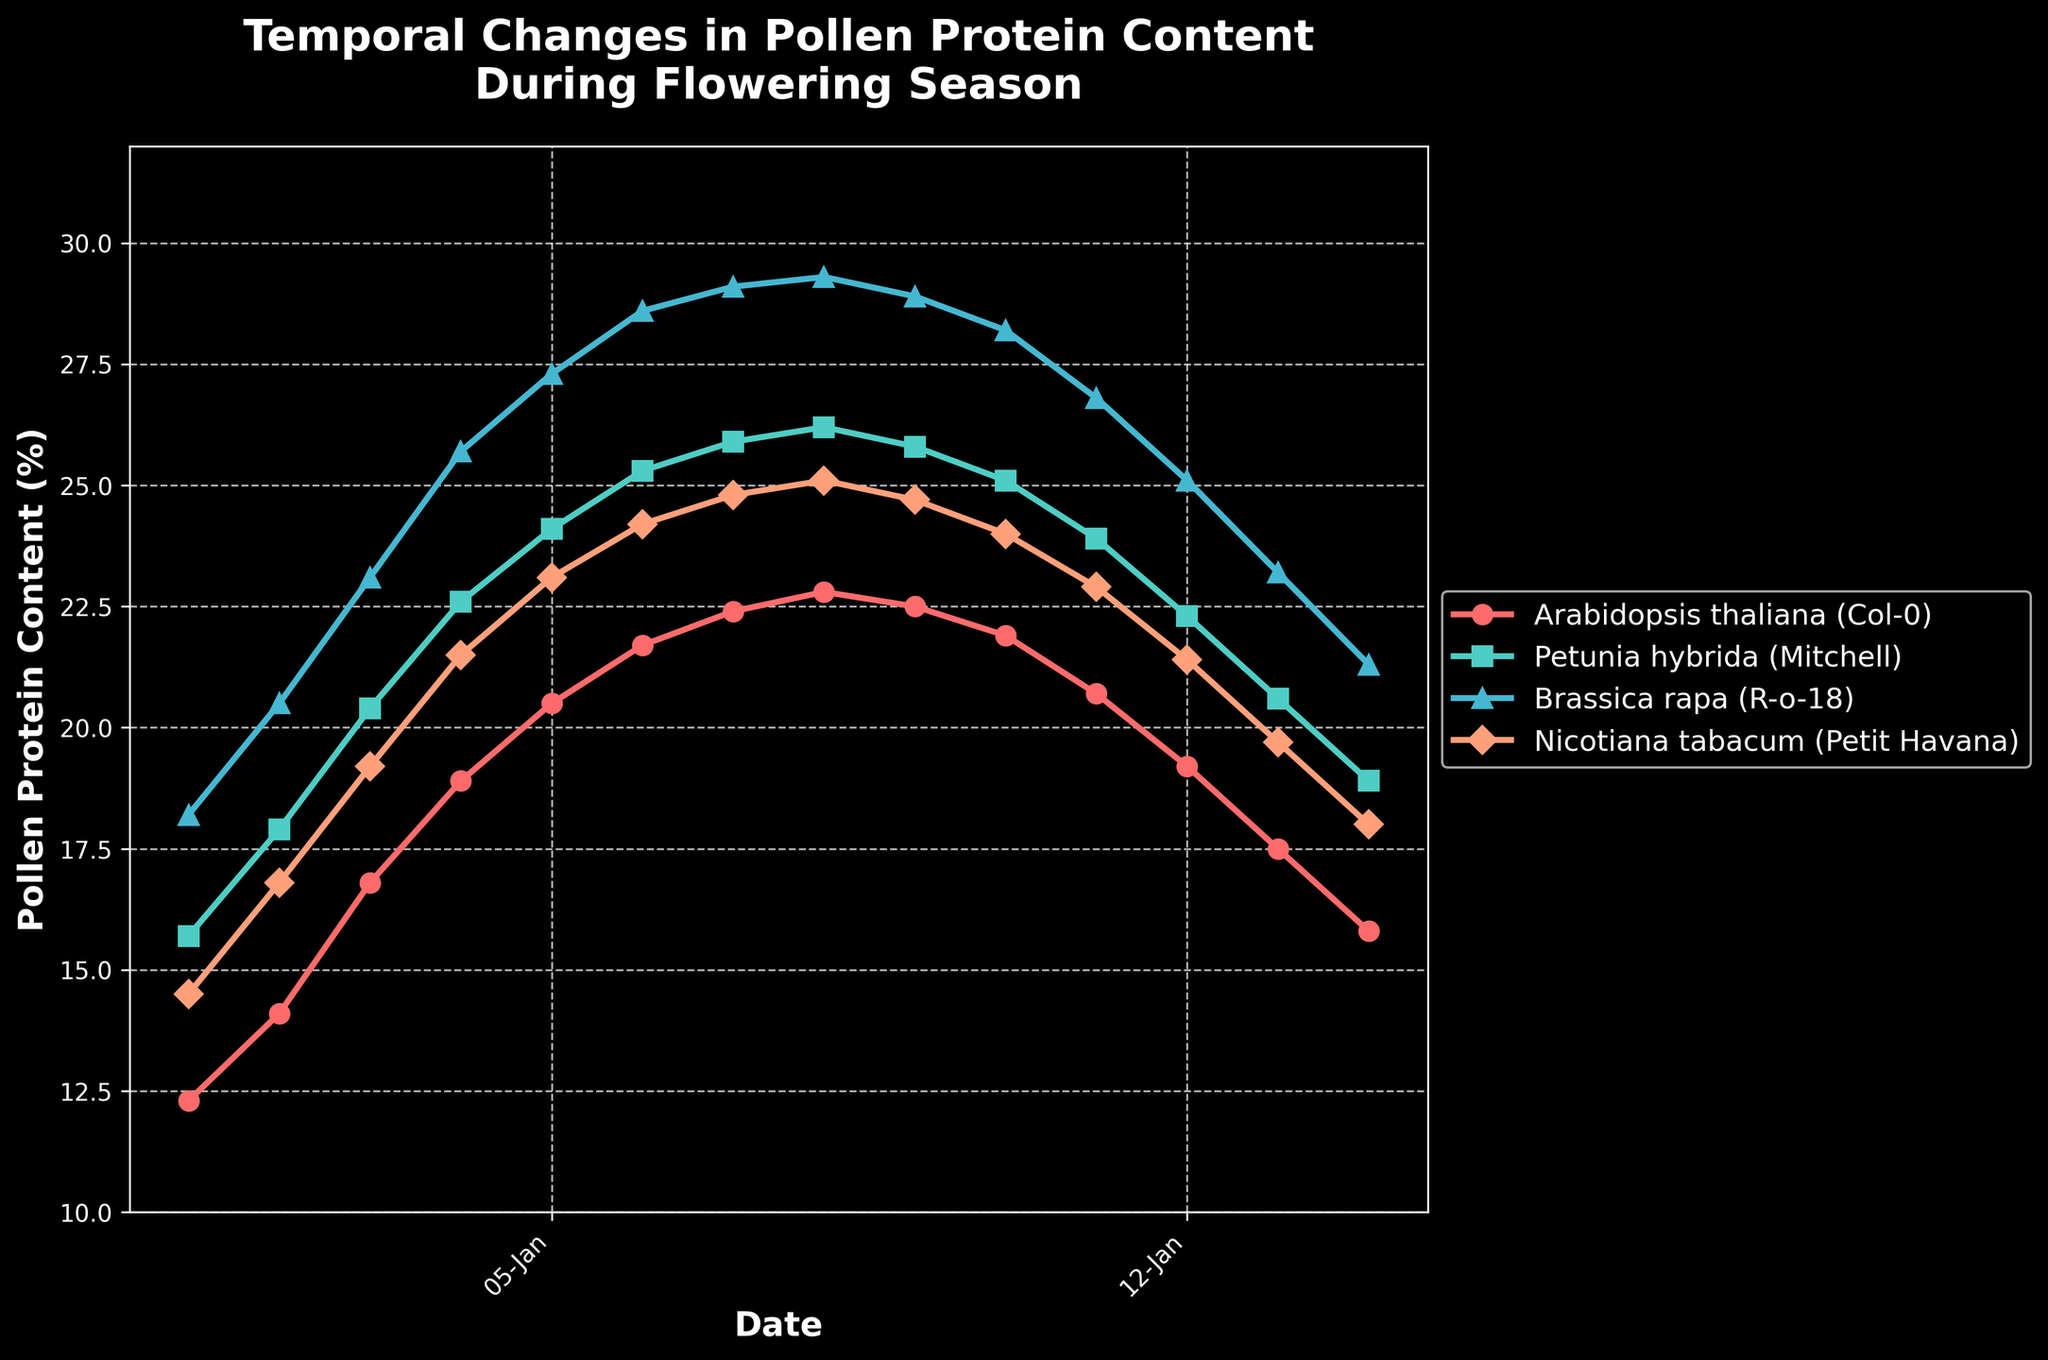What is the overall trend in pollen protein content for Arabidopsis thaliana (Col-0) from May to July? The pollen protein content for Arabidopsis thaliana (Col-0) starts at 12.3% in early May and steadily increases to a peak of 22.8% in mid-June. After mid-June, it begins to decrease gradually until it reaches 15.8% at the end of July.
Answer: Increasing then decreasing Which plant genotype has the highest pollen protein content on June 19th? On June 19th, the pollen protein contents are 22.8% for Arabidopsis thaliana (Col-0), 26.2% for Petunia hybrida (Mitchell), 29.3% for Brassica rapa (R-o-18), and 25.1% for Nicotiana tabacum (Petit Havana). Brassica rapa (R-o-18) has the highest pollen protein content.
Answer: Brassica rapa (R-o-18) Between June 5th and July 3rd, which plant genotype shows the least decrease in pollen protein content? Calculating the difference in pollen protein content between June 5th and July 3rd: Arabidopsis thaliana (Col-0) decreases from 21.7% to 21.9%, resulting in an increase of 0.2%; Petunia hybrida (Mitchell) decreases from 25.3% to 25.1%, resulting in a decrease of 0.2%; Brassica rapa (R-o-18) decreases from 28.6% to 28.2%, resulting in a decrease of 0.4%; Nicotiana tabacum (Petit Havana) decreases from 24.2% to 24.0%, resulting in a decrease of 0.2%. Arabidopsis thaliana (Col-0) shows the least decrease.
Answer: Arabidopsis thaliana (Col-0) What is the average pollen protein content for Nicotiana tabacum (Petit Havana) across the entire flowering season? Adding pollen protein content values for Nicotiana tabacum (Petit Havana): 14.5% + 16.8% + 19.2% + 21.5% + 23.1% + 24.2% + 24.8% + 25.1% + 24.7% + 24.0% + 22.9% + 21.4% + 19.7% + 18.0% = 280.9%. Dividing by the number of data points (14), 280.9 / 14 ≈ 20.06%.
Answer: 20.06% Which plant genotype experiences the largest peak pollen protein content and what is the value? The peak pollen protein contents for the plant genotypes are Arabidopsis thaliana (Col-0) with 22.8% on June 19th, Petunia hybrida (Mitchell) with 26.2% on June 19th, Brassica rapa (R-o-18) with 29.3% on June 19th, and Nicotiana tabacum (Petit Havana) with 25.1% on June 19th. Brassica rapa (R-o-18) has the largest peak at 29.3%.
Answer: Brassica rapa (R-o-18), 29.3% How does the pollen protein content of Petunia hybrida (Mitchell) compare to that of Nicotiana tabacum (Petit Havana) on July 10th? On July 10th, Petunia hybrida (Mitchell) has a pollen protein content of 23.9%, whereas Nicotiana tabacum (Petit Havana) has 22.9%. Petunia hybrida (Mitchell) has a higher pollen protein content.
Answer: Petunia hybrida (Mitchell) is higher Which week shows the steepest increase in pollen protein content for Brassica rapa (R-o-18)? The weekly differences in pollen protein content for Brassica rapa (R-o-18) are calculated between successive weeks. The difference that shows the steepest increase is between May 8th (20.5%) and May 15th (23.1%), which is an increase of 2.6 percentage points.
Answer: May 8th to May 15th What is the total increase in pollen protein content for Petunia hybrida (Mitchell) from May 1st to June 19th? On May 1st, Petunia hybrida (Mitchell) has a pollen protein content of 15.7%; on June 19th, it has 26.2%. The total increase is 26.2% - 15.7% = 10.5%.
Answer: 10.5% 